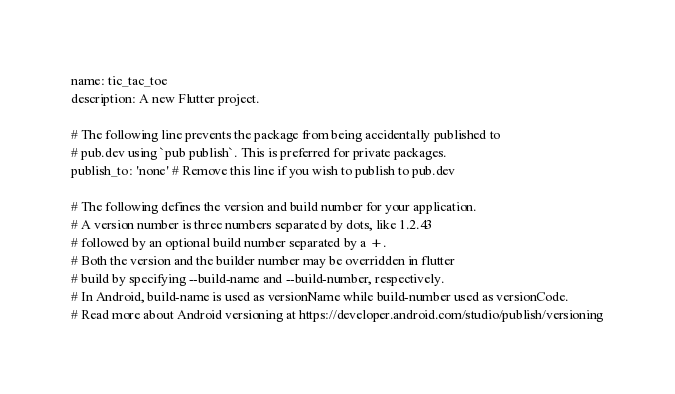<code> <loc_0><loc_0><loc_500><loc_500><_YAML_>name: tic_tac_toe
description: A new Flutter project.

# The following line prevents the package from being accidentally published to
# pub.dev using `pub publish`. This is preferred for private packages.
publish_to: 'none' # Remove this line if you wish to publish to pub.dev

# The following defines the version and build number for your application.
# A version number is three numbers separated by dots, like 1.2.43
# followed by an optional build number separated by a +.
# Both the version and the builder number may be overridden in flutter
# build by specifying --build-name and --build-number, respectively.
# In Android, build-name is used as versionName while build-number used as versionCode.
# Read more about Android versioning at https://developer.android.com/studio/publish/versioning</code> 